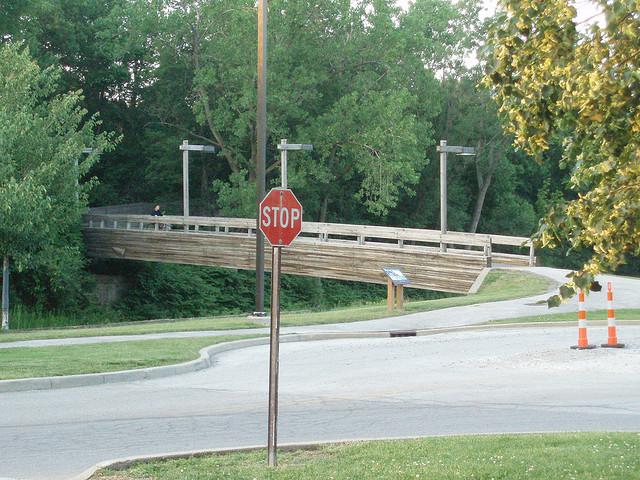Where is the stop sign?
Write a very short answer. In grass. Is this is a bridge?
Write a very short answer. Yes. How many orange cones are there?
Give a very brief answer. 2. 